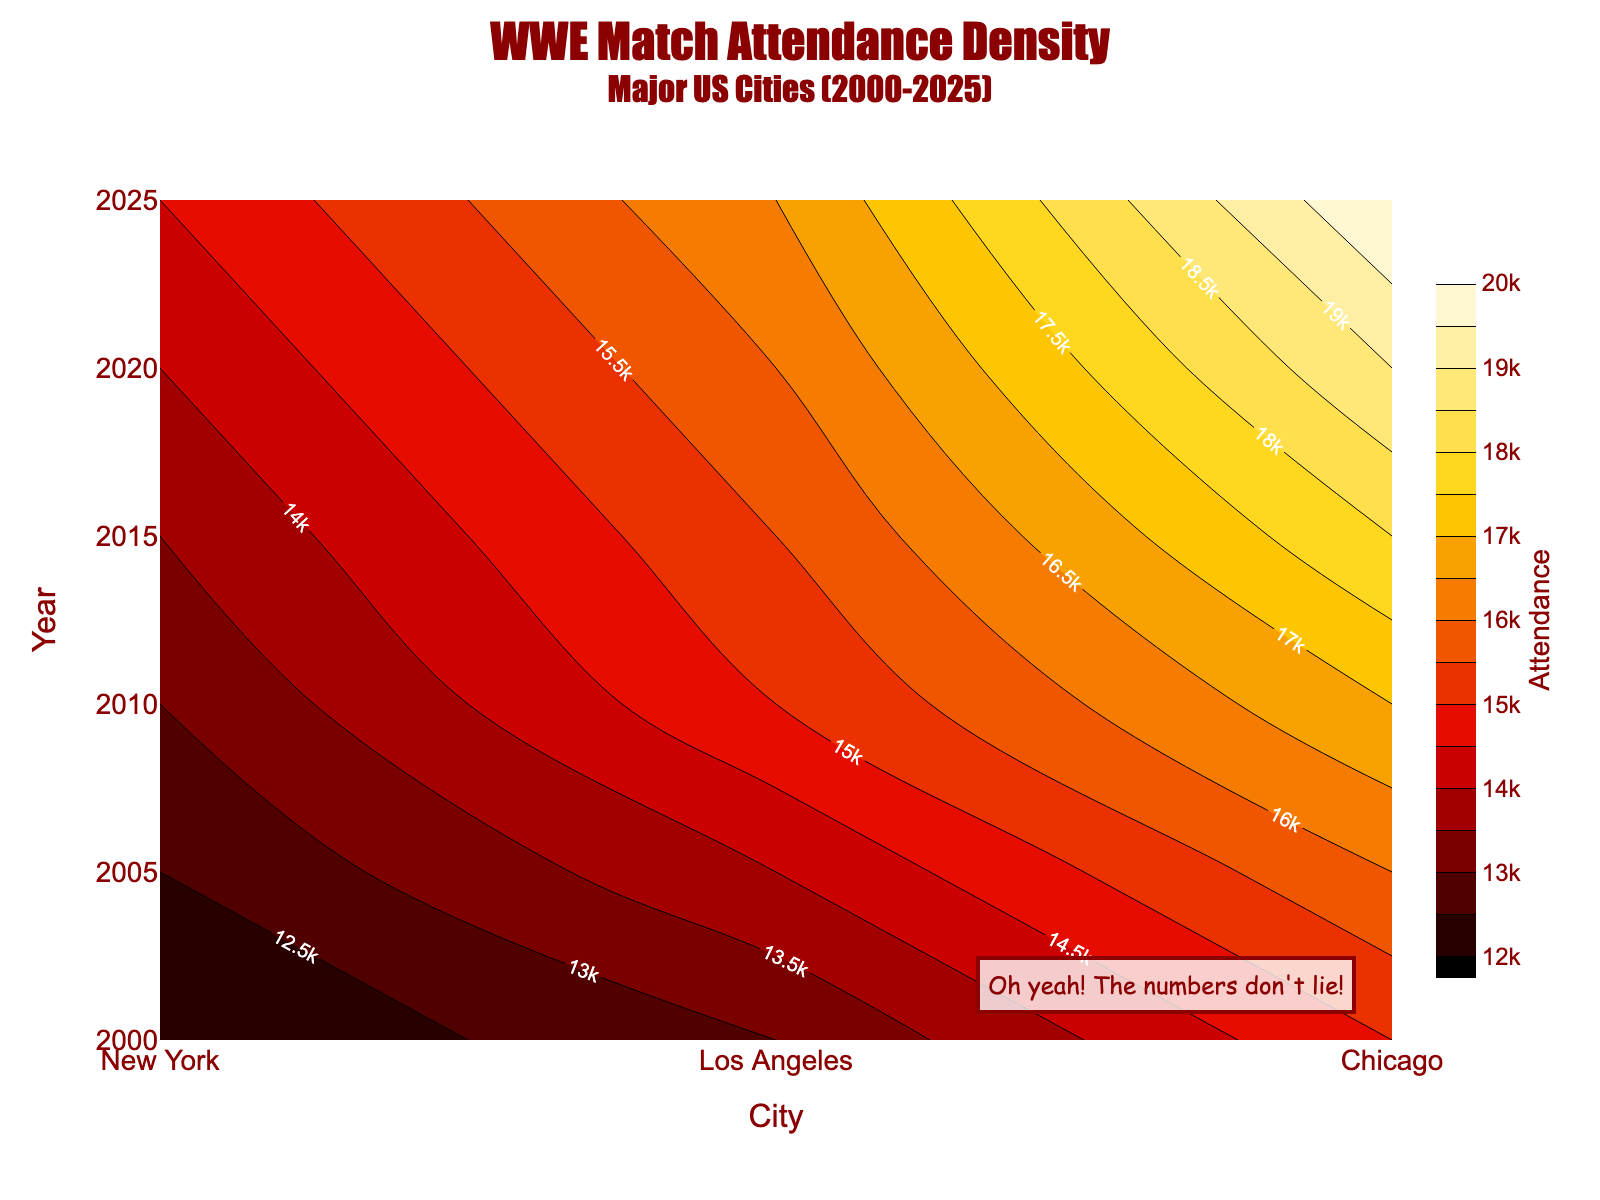What is the title of this contour plot? The title of the contour plot is located at the top of the figure and reads as "WWE Match Attendance Density" with a subtitle "Major US Cities (2000-2025)".
Answer: WWE Match Attendance Density Which year had the highest attendance in New York? Look at the contour lines and the labels within the "New York" column to determine where the highest attendance is. The year with the highest attendance label is 2025 with 20,000.
Answer: 2025 Compare the attendance between New York and Chicago in 2020. Which city had a higher attendance? Check the attendance values for both cities in the year 2020. New York has 19,000 and Chicago has 14,000.
Answer: New York How does the attendance trend in Los Angeles change from 2000 to 2025? Observe the contour levels in the "Los Angeles" column over the years from 2000 to 2025. The attendance increases from 13,000 in 2000 to 16,500 in 2025.
Answer: Increasing What is the average attendance in Chicago across all presented years? Identify the attendance values for Chicago in 2000, 2005, 2010, 2015, 2020, and 2025, and calculate the average: (12000 + 12500 + 13000 + 13500 + 14000 + 14500) / 6 = 13250.
Answer: 13,250 Between which two cities is the attendance difference the largest in 2015? Compare the attendance values for all three cities in 2015: New York (18000), Los Angeles (15500), Chicago (13500). Calculate differences and determine the largest: New York - Chicago (18000 - 13500 = 4500) is the largest.
Answer: New York and Chicago What does the color scale represent in this contour plot? The color scale, which ranges from light yellow to dark red, represents different levels of attendance, with lighter colors indicating lower attendance and darker colors indicating higher attendance.
Answer: Attendance Are there any annotations in the contour plot? Look for any additional text or marks within the plot area. There's a custom annotation near the bottom-right corner that reads "Oh yeah! The numbers don't lie!".
Answer: Yes Which city had the least variation in attendance over the years 2000 to 2025? Examine the contour lines' distribution for each city from 2000 to 2025. Los Angeles shows the least variation with attendance ranging from 13,000 to 16,500, compared to the wider ranges in New York and Chicago.
Answer: Los Angeles 